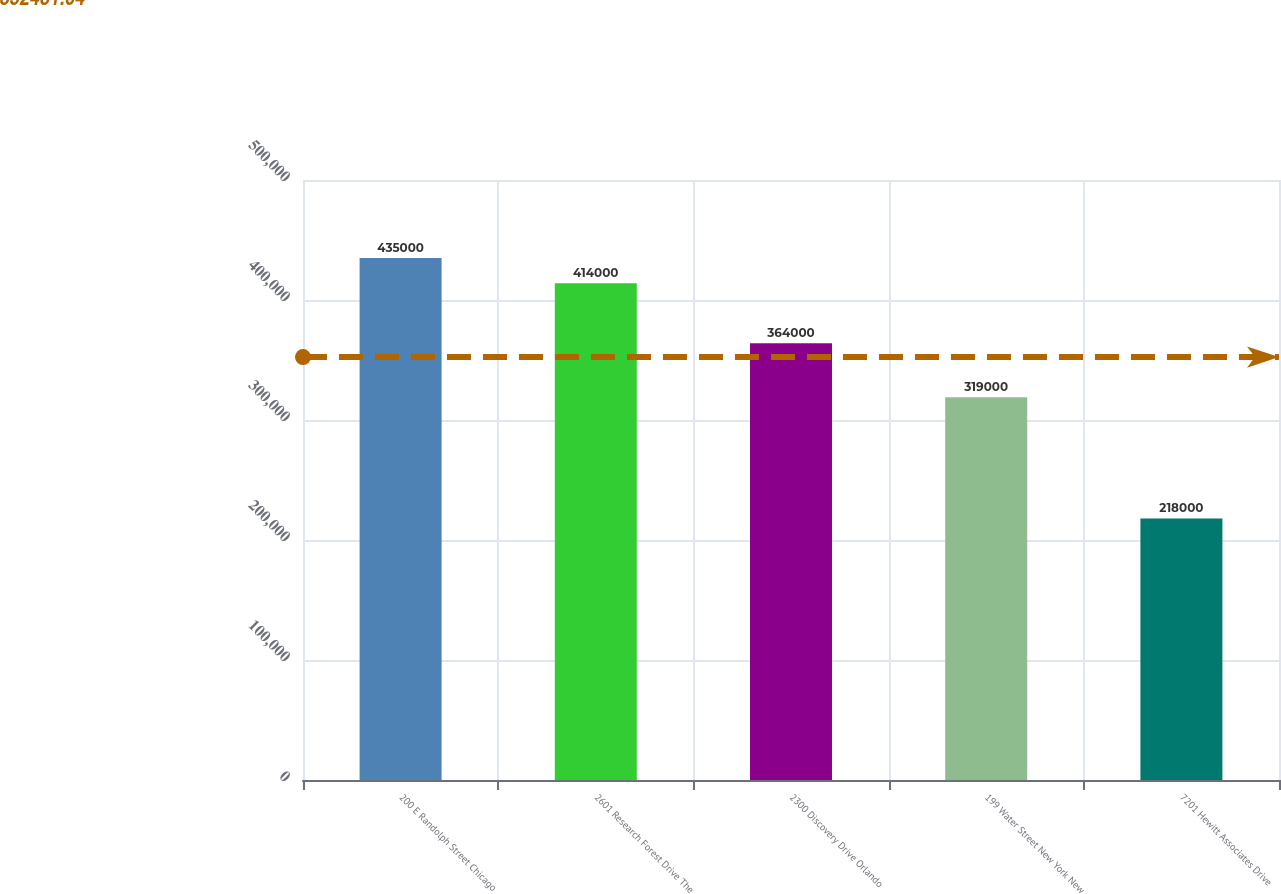Convert chart to OTSL. <chart><loc_0><loc_0><loc_500><loc_500><bar_chart><fcel>200 E Randolph Street Chicago<fcel>2601 Research Forest Drive The<fcel>2300 Discovery Drive Orlando<fcel>199 Water Street New York New<fcel>7201 Hewitt Associates Drive<nl><fcel>435000<fcel>414000<fcel>364000<fcel>319000<fcel>218000<nl></chart> 